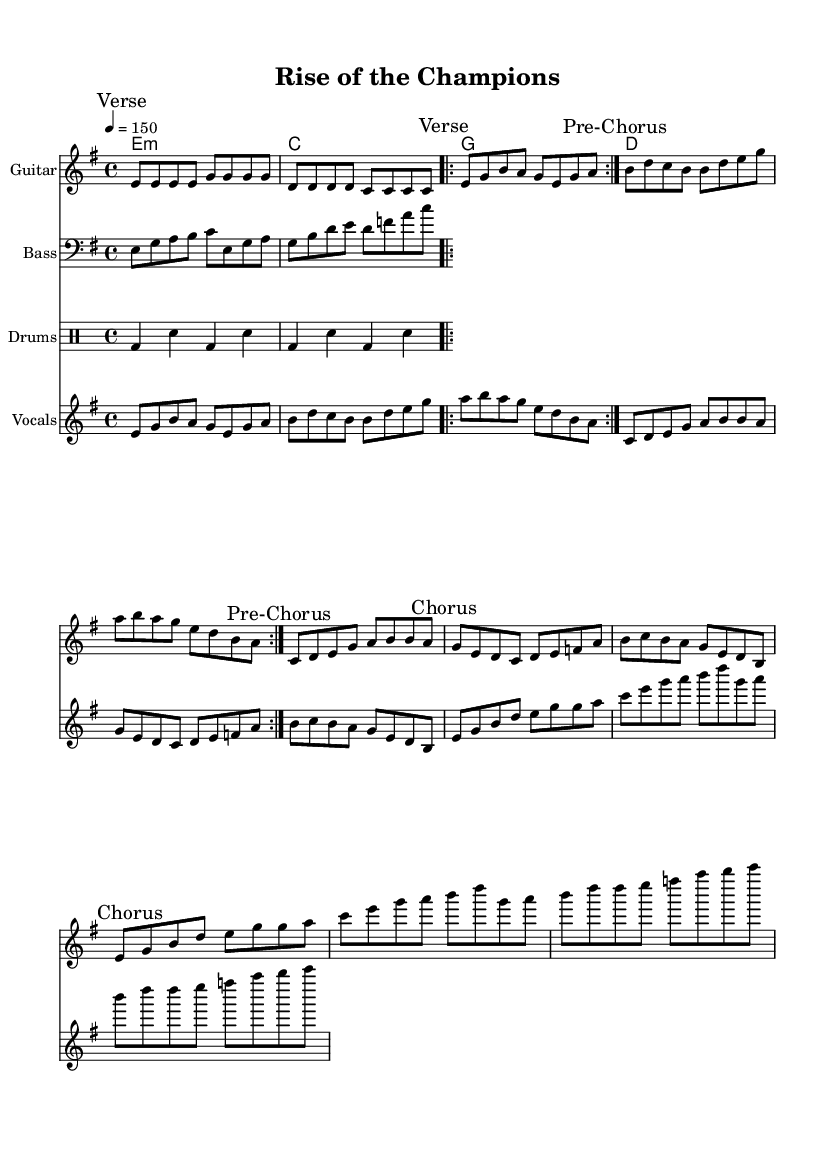What is the key signature of this music? The key signature of this piece is E minor, as indicated by the presence of one sharp (F#). This can be determined by the setting in the global block where the key is defined.
Answer: E minor What is the time signature of this music? The time signature is 4/4, which means there are four beats in each measure and the quarter note gets one beat. This is confirmed by the global settings in the piece.
Answer: 4/4 What is the tempo marking in this music? The tempo marking is 150 beats per minute, which is noted in the global block of the music where it indicates the speed of the piece.
Answer: 150 What is the main theme of the lyrics? The main theme of the lyrics emphasizes unity and perseverance, encouraging the team to face challenges together and rise as champions. This can be inferred from the lyrics presented in the sheet music under the "Lyrics" section.
Answer: Unity and perseverance How many times is the verse repeated? The verse is repeated twice, which is indicated by the text 'repeat volta 2' in the notation, meaning it will play the section of the verse two times.
Answer: 2 What type of metal elements are used in the musical structure? This piece incorporates driving guitar riffs, powerful vocal lines, and energetic drum patterns characteristic of motivational metal anthems, creating an anthemic and uplifting sound typical for team rallies. This can be recognized by the instrumentation and rhythmic style present in the score.
Answer: Driving guitar riffs What is the significance of the pre-chorus in the song structure? The pre-chorus serves to build tension and lead into the chorus, which is a common structural element in metal music. It transitions the listener from the verse to the more powerful and impactful chorus, emphasizing the dramatic rise in energy. This can be seen in the marking of the sections within the sheet music.
Answer: Build tension 